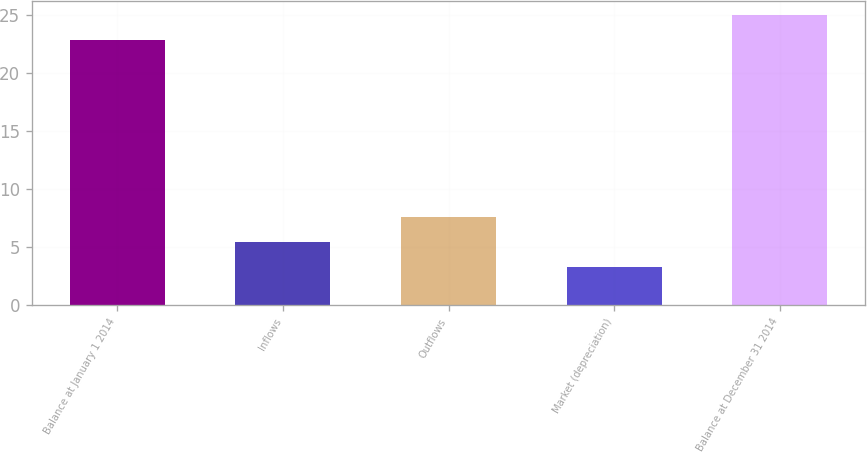Convert chart to OTSL. <chart><loc_0><loc_0><loc_500><loc_500><bar_chart><fcel>Balance at January 1 2014<fcel>Inflows<fcel>Outflows<fcel>Market (depreciation)<fcel>Balance at December 31 2014<nl><fcel>22.8<fcel>5.45<fcel>7.6<fcel>3.3<fcel>24.95<nl></chart> 